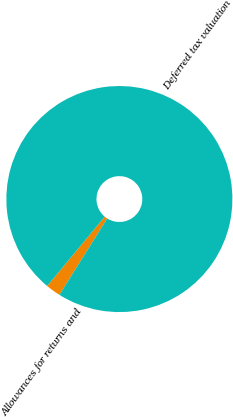Convert chart. <chart><loc_0><loc_0><loc_500><loc_500><pie_chart><fcel>Allowances for returns and<fcel>Deferred tax valuation<nl><fcel>2.13%<fcel>97.87%<nl></chart> 